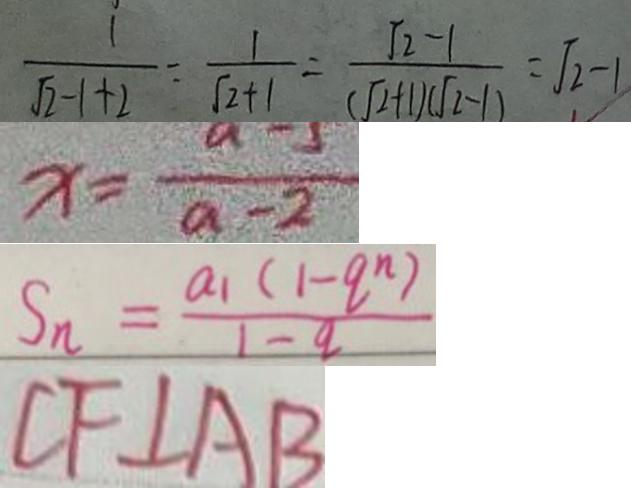<formula> <loc_0><loc_0><loc_500><loc_500>\frac { 1 } { \sqrt { 2 } - 1 + 2 } = \frac { 1 } { \sqrt { 2 } + 1 } = \frac { \sqrt { 2 } - 1 } { ( \sqrt { 2 } + 1 ) ( \sqrt { 2 } - 1 ) } = \sqrt { 2 } - 1 
 x = \frac { a - 5 } { a - 2 } 
 S _ { n } = \frac { a _ { 1 } ( 1 - q ^ { n } ) } { 1 - q } 
 C F \bot A B</formula> 